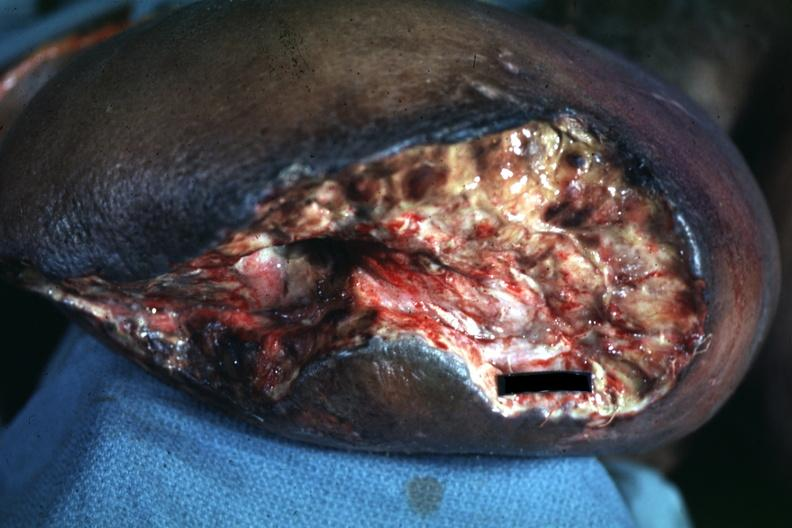s amputation stump infected present?
Answer the question using a single word or phrase. Yes 